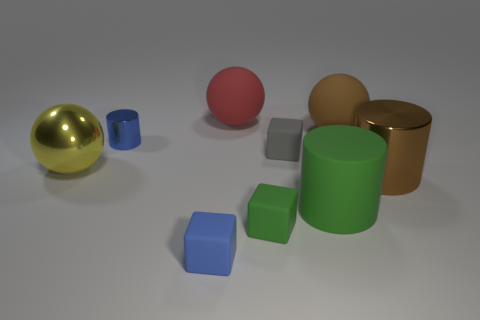Subtract all brown balls. How many balls are left? 2 Subtract all blue cubes. How many cubes are left? 2 Subtract 1 cubes. How many cubes are left? 2 Subtract all blocks. How many objects are left? 6 Add 1 gray rubber cubes. How many objects exist? 10 Subtract all gray cylinders. Subtract all yellow balls. How many cylinders are left? 3 Subtract all gray rubber blocks. Subtract all big cylinders. How many objects are left? 6 Add 1 brown metal things. How many brown metal things are left? 2 Add 5 big shiny cylinders. How many big shiny cylinders exist? 6 Subtract 0 cyan cylinders. How many objects are left? 9 